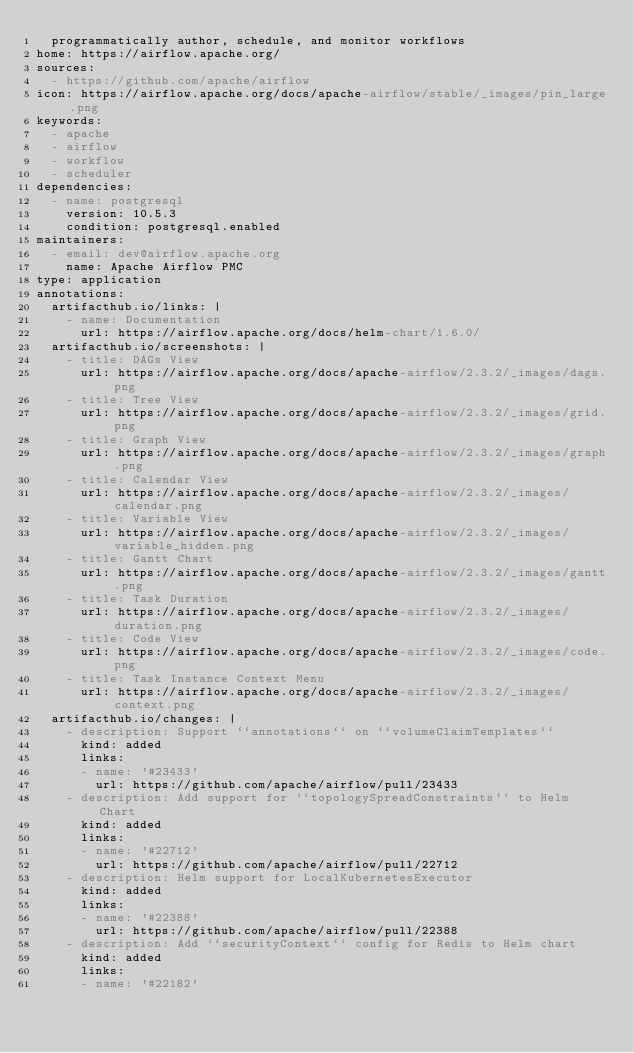Convert code to text. <code><loc_0><loc_0><loc_500><loc_500><_YAML_>  programmatically author, schedule, and monitor workflows
home: https://airflow.apache.org/
sources:
  - https://github.com/apache/airflow
icon: https://airflow.apache.org/docs/apache-airflow/stable/_images/pin_large.png
keywords:
  - apache
  - airflow
  - workflow
  - scheduler
dependencies:
  - name: postgresql
    version: 10.5.3
    condition: postgresql.enabled
maintainers:
  - email: dev@airflow.apache.org
    name: Apache Airflow PMC
type: application
annotations:
  artifacthub.io/links: |
    - name: Documentation
      url: https://airflow.apache.org/docs/helm-chart/1.6.0/
  artifacthub.io/screenshots: |
    - title: DAGs View
      url: https://airflow.apache.org/docs/apache-airflow/2.3.2/_images/dags.png
    - title: Tree View
      url: https://airflow.apache.org/docs/apache-airflow/2.3.2/_images/grid.png
    - title: Graph View
      url: https://airflow.apache.org/docs/apache-airflow/2.3.2/_images/graph.png
    - title: Calendar View
      url: https://airflow.apache.org/docs/apache-airflow/2.3.2/_images/calendar.png
    - title: Variable View
      url: https://airflow.apache.org/docs/apache-airflow/2.3.2/_images/variable_hidden.png
    - title: Gantt Chart
      url: https://airflow.apache.org/docs/apache-airflow/2.3.2/_images/gantt.png
    - title: Task Duration
      url: https://airflow.apache.org/docs/apache-airflow/2.3.2/_images/duration.png
    - title: Code View
      url: https://airflow.apache.org/docs/apache-airflow/2.3.2/_images/code.png
    - title: Task Instance Context Menu
      url: https://airflow.apache.org/docs/apache-airflow/2.3.2/_images/context.png
  artifacthub.io/changes: |
    - description: Support ``annotations`` on ``volumeClaimTemplates``
      kind: added
      links:
      - name: '#23433'
        url: https://github.com/apache/airflow/pull/23433
    - description: Add support for ``topologySpreadConstraints`` to Helm Chart
      kind: added
      links:
      - name: '#22712'
        url: https://github.com/apache/airflow/pull/22712
    - description: Helm support for LocalKubernetesExecutor
      kind: added
      links:
      - name: '#22388'
        url: https://github.com/apache/airflow/pull/22388
    - description: Add ``securityContext`` config for Redis to Helm chart
      kind: added
      links:
      - name: '#22182'</code> 